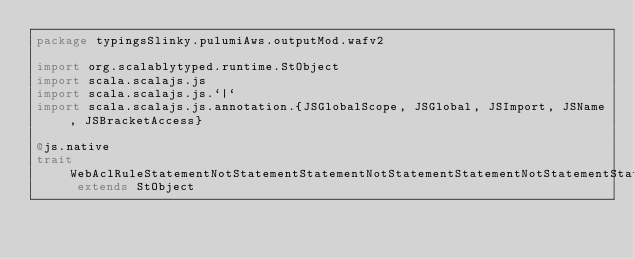Convert code to text. <code><loc_0><loc_0><loc_500><loc_500><_Scala_>package typingsSlinky.pulumiAws.outputMod.wafv2

import org.scalablytyped.runtime.StObject
import scala.scalajs.js
import scala.scalajs.js.`|`
import scala.scalajs.js.annotation.{JSGlobalScope, JSGlobal, JSImport, JSName, JSBracketAccess}

@js.native
trait WebAclRuleStatementNotStatementStatementNotStatementStatementNotStatementStatementByteMatchStatementFieldToMatchQueryString extends StObject
</code> 